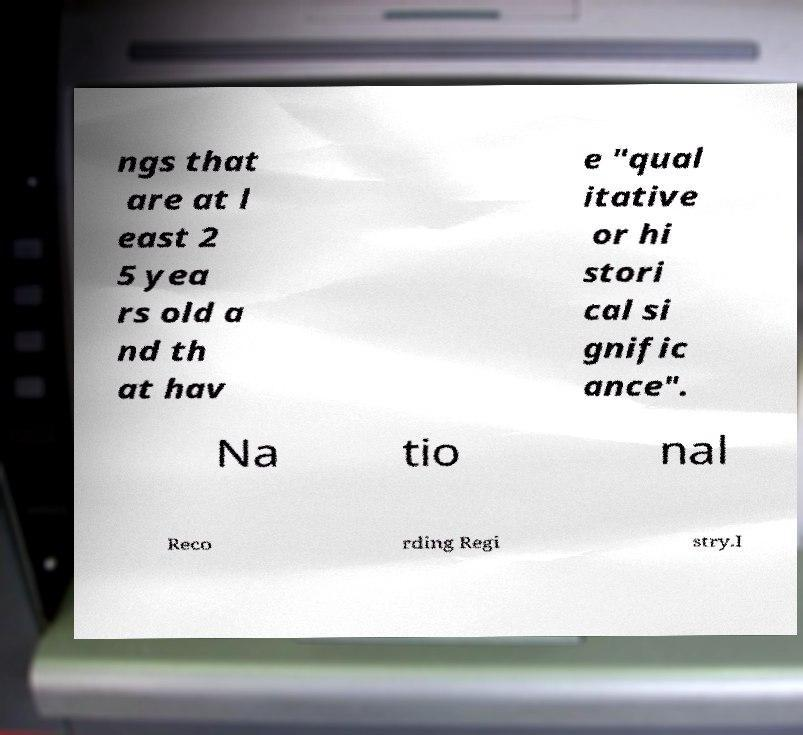Could you extract and type out the text from this image? ngs that are at l east 2 5 yea rs old a nd th at hav e "qual itative or hi stori cal si gnific ance". Na tio nal Reco rding Regi stry.I 